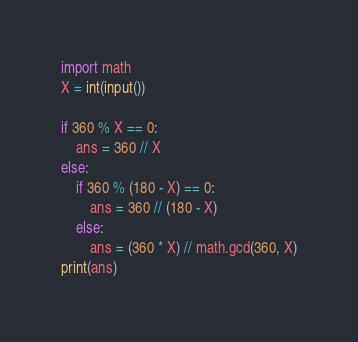Convert code to text. <code><loc_0><loc_0><loc_500><loc_500><_Python_>import math
X = int(input())

if 360 % X == 0:
    ans = 360 // X
else:
    if 360 % (180 - X) == 0:
        ans = 360 // (180 - X)
    else:
        ans = (360 * X) // math.gcd(360, X)
print(ans)</code> 